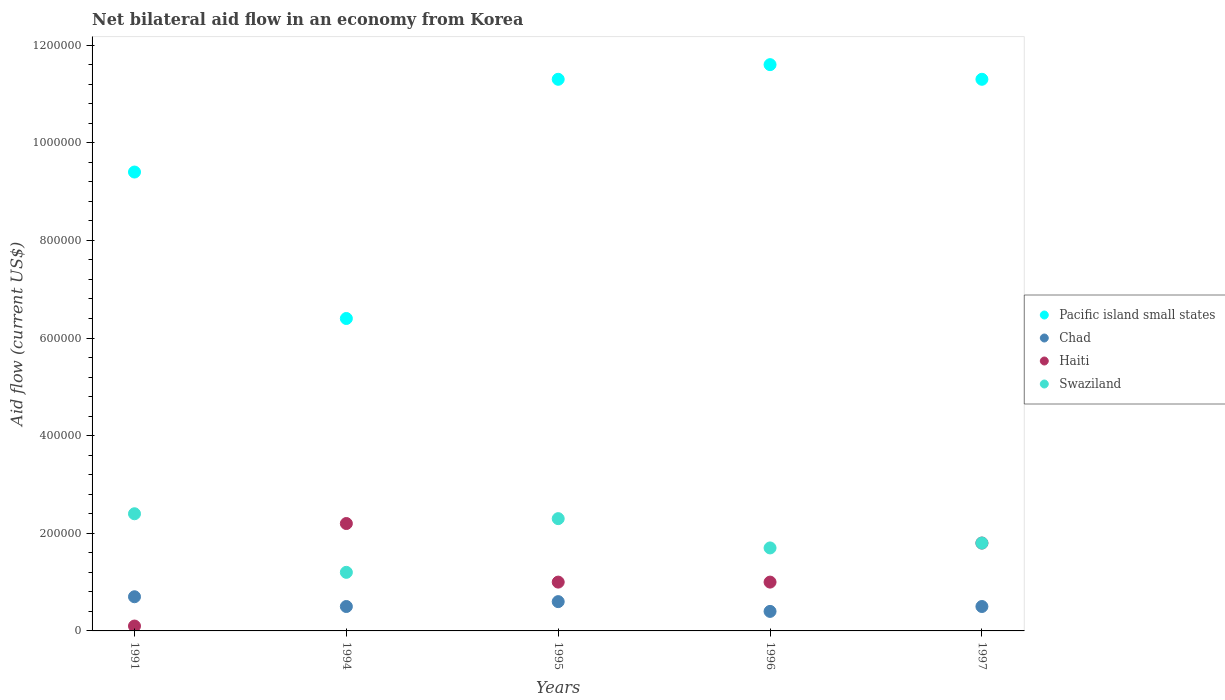What is the net bilateral aid flow in Pacific island small states in 1991?
Provide a short and direct response. 9.40e+05. Across all years, what is the maximum net bilateral aid flow in Swaziland?
Keep it short and to the point. 2.40e+05. Across all years, what is the minimum net bilateral aid flow in Swaziland?
Offer a terse response. 1.20e+05. In which year was the net bilateral aid flow in Chad maximum?
Offer a very short reply. 1991. What is the total net bilateral aid flow in Swaziland in the graph?
Your response must be concise. 9.40e+05. What is the difference between the net bilateral aid flow in Pacific island small states in 1994 and that in 1995?
Make the answer very short. -4.90e+05. What is the difference between the net bilateral aid flow in Haiti in 1991 and the net bilateral aid flow in Swaziland in 1995?
Provide a short and direct response. -2.20e+05. In the year 1994, what is the difference between the net bilateral aid flow in Swaziland and net bilateral aid flow in Pacific island small states?
Your answer should be compact. -5.20e+05. In how many years, is the net bilateral aid flow in Chad greater than 160000 US$?
Make the answer very short. 0. What is the ratio of the net bilateral aid flow in Haiti in 1991 to that in 1994?
Offer a terse response. 0.05. Is the sum of the net bilateral aid flow in Swaziland in 1994 and 1995 greater than the maximum net bilateral aid flow in Pacific island small states across all years?
Make the answer very short. No. Does the net bilateral aid flow in Haiti monotonically increase over the years?
Provide a succinct answer. No. Is the net bilateral aid flow in Pacific island small states strictly less than the net bilateral aid flow in Haiti over the years?
Provide a succinct answer. No. What is the difference between two consecutive major ticks on the Y-axis?
Provide a succinct answer. 2.00e+05. Does the graph contain grids?
Make the answer very short. No. Where does the legend appear in the graph?
Keep it short and to the point. Center right. How many legend labels are there?
Offer a terse response. 4. How are the legend labels stacked?
Ensure brevity in your answer.  Vertical. What is the title of the graph?
Your answer should be compact. Net bilateral aid flow in an economy from Korea. Does "Brazil" appear as one of the legend labels in the graph?
Your response must be concise. No. What is the label or title of the X-axis?
Offer a very short reply. Years. What is the label or title of the Y-axis?
Offer a very short reply. Aid flow (current US$). What is the Aid flow (current US$) of Pacific island small states in 1991?
Your answer should be very brief. 9.40e+05. What is the Aid flow (current US$) in Haiti in 1991?
Make the answer very short. 10000. What is the Aid flow (current US$) of Pacific island small states in 1994?
Ensure brevity in your answer.  6.40e+05. What is the Aid flow (current US$) in Chad in 1994?
Provide a succinct answer. 5.00e+04. What is the Aid flow (current US$) in Pacific island small states in 1995?
Keep it short and to the point. 1.13e+06. What is the Aid flow (current US$) of Chad in 1995?
Keep it short and to the point. 6.00e+04. What is the Aid flow (current US$) in Swaziland in 1995?
Give a very brief answer. 2.30e+05. What is the Aid flow (current US$) of Pacific island small states in 1996?
Provide a short and direct response. 1.16e+06. What is the Aid flow (current US$) in Haiti in 1996?
Offer a very short reply. 1.00e+05. What is the Aid flow (current US$) in Pacific island small states in 1997?
Offer a terse response. 1.13e+06. What is the Aid flow (current US$) in Haiti in 1997?
Offer a very short reply. 1.80e+05. Across all years, what is the maximum Aid flow (current US$) of Pacific island small states?
Give a very brief answer. 1.16e+06. Across all years, what is the maximum Aid flow (current US$) in Swaziland?
Your response must be concise. 2.40e+05. Across all years, what is the minimum Aid flow (current US$) of Pacific island small states?
Offer a very short reply. 6.40e+05. Across all years, what is the minimum Aid flow (current US$) of Haiti?
Your answer should be compact. 10000. What is the total Aid flow (current US$) of Haiti in the graph?
Your answer should be very brief. 6.10e+05. What is the total Aid flow (current US$) of Swaziland in the graph?
Keep it short and to the point. 9.40e+05. What is the difference between the Aid flow (current US$) of Pacific island small states in 1991 and that in 1994?
Provide a short and direct response. 3.00e+05. What is the difference between the Aid flow (current US$) of Swaziland in 1991 and that in 1994?
Offer a very short reply. 1.20e+05. What is the difference between the Aid flow (current US$) in Pacific island small states in 1991 and that in 1995?
Make the answer very short. -1.90e+05. What is the difference between the Aid flow (current US$) of Chad in 1991 and that in 1995?
Offer a terse response. 10000. What is the difference between the Aid flow (current US$) in Swaziland in 1991 and that in 1995?
Keep it short and to the point. 10000. What is the difference between the Aid flow (current US$) in Chad in 1991 and that in 1996?
Offer a terse response. 3.00e+04. What is the difference between the Aid flow (current US$) in Pacific island small states in 1991 and that in 1997?
Offer a terse response. -1.90e+05. What is the difference between the Aid flow (current US$) of Haiti in 1991 and that in 1997?
Offer a terse response. -1.70e+05. What is the difference between the Aid flow (current US$) of Swaziland in 1991 and that in 1997?
Your answer should be very brief. 6.00e+04. What is the difference between the Aid flow (current US$) in Pacific island small states in 1994 and that in 1995?
Your response must be concise. -4.90e+05. What is the difference between the Aid flow (current US$) in Chad in 1994 and that in 1995?
Provide a succinct answer. -10000. What is the difference between the Aid flow (current US$) in Haiti in 1994 and that in 1995?
Offer a terse response. 1.20e+05. What is the difference between the Aid flow (current US$) in Swaziland in 1994 and that in 1995?
Offer a terse response. -1.10e+05. What is the difference between the Aid flow (current US$) of Pacific island small states in 1994 and that in 1996?
Provide a succinct answer. -5.20e+05. What is the difference between the Aid flow (current US$) in Haiti in 1994 and that in 1996?
Provide a short and direct response. 1.20e+05. What is the difference between the Aid flow (current US$) of Swaziland in 1994 and that in 1996?
Provide a succinct answer. -5.00e+04. What is the difference between the Aid flow (current US$) of Pacific island small states in 1994 and that in 1997?
Give a very brief answer. -4.90e+05. What is the difference between the Aid flow (current US$) of Pacific island small states in 1995 and that in 1996?
Make the answer very short. -3.00e+04. What is the difference between the Aid flow (current US$) in Haiti in 1995 and that in 1996?
Make the answer very short. 0. What is the difference between the Aid flow (current US$) of Chad in 1995 and that in 1997?
Give a very brief answer. 10000. What is the difference between the Aid flow (current US$) in Haiti in 1995 and that in 1997?
Provide a short and direct response. -8.00e+04. What is the difference between the Aid flow (current US$) in Haiti in 1996 and that in 1997?
Your response must be concise. -8.00e+04. What is the difference between the Aid flow (current US$) in Pacific island small states in 1991 and the Aid flow (current US$) in Chad in 1994?
Give a very brief answer. 8.90e+05. What is the difference between the Aid flow (current US$) of Pacific island small states in 1991 and the Aid flow (current US$) of Haiti in 1994?
Your response must be concise. 7.20e+05. What is the difference between the Aid flow (current US$) in Pacific island small states in 1991 and the Aid flow (current US$) in Swaziland in 1994?
Your answer should be compact. 8.20e+05. What is the difference between the Aid flow (current US$) of Haiti in 1991 and the Aid flow (current US$) of Swaziland in 1994?
Provide a short and direct response. -1.10e+05. What is the difference between the Aid flow (current US$) in Pacific island small states in 1991 and the Aid flow (current US$) in Chad in 1995?
Make the answer very short. 8.80e+05. What is the difference between the Aid flow (current US$) in Pacific island small states in 1991 and the Aid flow (current US$) in Haiti in 1995?
Your answer should be compact. 8.40e+05. What is the difference between the Aid flow (current US$) of Pacific island small states in 1991 and the Aid flow (current US$) of Swaziland in 1995?
Provide a short and direct response. 7.10e+05. What is the difference between the Aid flow (current US$) in Pacific island small states in 1991 and the Aid flow (current US$) in Chad in 1996?
Make the answer very short. 9.00e+05. What is the difference between the Aid flow (current US$) of Pacific island small states in 1991 and the Aid flow (current US$) of Haiti in 1996?
Your answer should be very brief. 8.40e+05. What is the difference between the Aid flow (current US$) in Pacific island small states in 1991 and the Aid flow (current US$) in Swaziland in 1996?
Make the answer very short. 7.70e+05. What is the difference between the Aid flow (current US$) in Chad in 1991 and the Aid flow (current US$) in Swaziland in 1996?
Give a very brief answer. -1.00e+05. What is the difference between the Aid flow (current US$) in Pacific island small states in 1991 and the Aid flow (current US$) in Chad in 1997?
Your response must be concise. 8.90e+05. What is the difference between the Aid flow (current US$) of Pacific island small states in 1991 and the Aid flow (current US$) of Haiti in 1997?
Your answer should be compact. 7.60e+05. What is the difference between the Aid flow (current US$) in Pacific island small states in 1991 and the Aid flow (current US$) in Swaziland in 1997?
Provide a succinct answer. 7.60e+05. What is the difference between the Aid flow (current US$) in Chad in 1991 and the Aid flow (current US$) in Haiti in 1997?
Make the answer very short. -1.10e+05. What is the difference between the Aid flow (current US$) of Pacific island small states in 1994 and the Aid flow (current US$) of Chad in 1995?
Make the answer very short. 5.80e+05. What is the difference between the Aid flow (current US$) of Pacific island small states in 1994 and the Aid flow (current US$) of Haiti in 1995?
Make the answer very short. 5.40e+05. What is the difference between the Aid flow (current US$) in Pacific island small states in 1994 and the Aid flow (current US$) in Swaziland in 1995?
Give a very brief answer. 4.10e+05. What is the difference between the Aid flow (current US$) in Chad in 1994 and the Aid flow (current US$) in Haiti in 1995?
Your response must be concise. -5.00e+04. What is the difference between the Aid flow (current US$) of Pacific island small states in 1994 and the Aid flow (current US$) of Chad in 1996?
Offer a terse response. 6.00e+05. What is the difference between the Aid flow (current US$) of Pacific island small states in 1994 and the Aid flow (current US$) of Haiti in 1996?
Keep it short and to the point. 5.40e+05. What is the difference between the Aid flow (current US$) of Chad in 1994 and the Aid flow (current US$) of Haiti in 1996?
Keep it short and to the point. -5.00e+04. What is the difference between the Aid flow (current US$) in Pacific island small states in 1994 and the Aid flow (current US$) in Chad in 1997?
Provide a succinct answer. 5.90e+05. What is the difference between the Aid flow (current US$) in Pacific island small states in 1994 and the Aid flow (current US$) in Swaziland in 1997?
Provide a short and direct response. 4.60e+05. What is the difference between the Aid flow (current US$) in Chad in 1994 and the Aid flow (current US$) in Swaziland in 1997?
Offer a terse response. -1.30e+05. What is the difference between the Aid flow (current US$) in Haiti in 1994 and the Aid flow (current US$) in Swaziland in 1997?
Give a very brief answer. 4.00e+04. What is the difference between the Aid flow (current US$) of Pacific island small states in 1995 and the Aid flow (current US$) of Chad in 1996?
Your answer should be very brief. 1.09e+06. What is the difference between the Aid flow (current US$) of Pacific island small states in 1995 and the Aid flow (current US$) of Haiti in 1996?
Provide a succinct answer. 1.03e+06. What is the difference between the Aid flow (current US$) of Pacific island small states in 1995 and the Aid flow (current US$) of Swaziland in 1996?
Your response must be concise. 9.60e+05. What is the difference between the Aid flow (current US$) of Chad in 1995 and the Aid flow (current US$) of Swaziland in 1996?
Your answer should be compact. -1.10e+05. What is the difference between the Aid flow (current US$) of Pacific island small states in 1995 and the Aid flow (current US$) of Chad in 1997?
Your answer should be compact. 1.08e+06. What is the difference between the Aid flow (current US$) in Pacific island small states in 1995 and the Aid flow (current US$) in Haiti in 1997?
Offer a terse response. 9.50e+05. What is the difference between the Aid flow (current US$) of Pacific island small states in 1995 and the Aid flow (current US$) of Swaziland in 1997?
Offer a very short reply. 9.50e+05. What is the difference between the Aid flow (current US$) in Chad in 1995 and the Aid flow (current US$) in Haiti in 1997?
Keep it short and to the point. -1.20e+05. What is the difference between the Aid flow (current US$) of Haiti in 1995 and the Aid flow (current US$) of Swaziland in 1997?
Give a very brief answer. -8.00e+04. What is the difference between the Aid flow (current US$) in Pacific island small states in 1996 and the Aid flow (current US$) in Chad in 1997?
Your answer should be compact. 1.11e+06. What is the difference between the Aid flow (current US$) in Pacific island small states in 1996 and the Aid flow (current US$) in Haiti in 1997?
Give a very brief answer. 9.80e+05. What is the difference between the Aid flow (current US$) of Pacific island small states in 1996 and the Aid flow (current US$) of Swaziland in 1997?
Offer a terse response. 9.80e+05. What is the difference between the Aid flow (current US$) of Chad in 1996 and the Aid flow (current US$) of Haiti in 1997?
Ensure brevity in your answer.  -1.40e+05. What is the difference between the Aid flow (current US$) in Chad in 1996 and the Aid flow (current US$) in Swaziland in 1997?
Offer a very short reply. -1.40e+05. What is the average Aid flow (current US$) of Chad per year?
Give a very brief answer. 5.40e+04. What is the average Aid flow (current US$) in Haiti per year?
Your answer should be very brief. 1.22e+05. What is the average Aid flow (current US$) of Swaziland per year?
Provide a short and direct response. 1.88e+05. In the year 1991, what is the difference between the Aid flow (current US$) in Pacific island small states and Aid flow (current US$) in Chad?
Your answer should be compact. 8.70e+05. In the year 1991, what is the difference between the Aid flow (current US$) in Pacific island small states and Aid flow (current US$) in Haiti?
Offer a terse response. 9.30e+05. In the year 1991, what is the difference between the Aid flow (current US$) in Pacific island small states and Aid flow (current US$) in Swaziland?
Your answer should be compact. 7.00e+05. In the year 1991, what is the difference between the Aid flow (current US$) in Chad and Aid flow (current US$) in Haiti?
Your answer should be very brief. 6.00e+04. In the year 1991, what is the difference between the Aid flow (current US$) in Haiti and Aid flow (current US$) in Swaziland?
Ensure brevity in your answer.  -2.30e+05. In the year 1994, what is the difference between the Aid flow (current US$) of Pacific island small states and Aid flow (current US$) of Chad?
Make the answer very short. 5.90e+05. In the year 1994, what is the difference between the Aid flow (current US$) in Pacific island small states and Aid flow (current US$) in Haiti?
Make the answer very short. 4.20e+05. In the year 1994, what is the difference between the Aid flow (current US$) of Pacific island small states and Aid flow (current US$) of Swaziland?
Your answer should be compact. 5.20e+05. In the year 1994, what is the difference between the Aid flow (current US$) of Chad and Aid flow (current US$) of Swaziland?
Give a very brief answer. -7.00e+04. In the year 1995, what is the difference between the Aid flow (current US$) in Pacific island small states and Aid flow (current US$) in Chad?
Give a very brief answer. 1.07e+06. In the year 1995, what is the difference between the Aid flow (current US$) in Pacific island small states and Aid flow (current US$) in Haiti?
Ensure brevity in your answer.  1.03e+06. In the year 1995, what is the difference between the Aid flow (current US$) in Chad and Aid flow (current US$) in Haiti?
Make the answer very short. -4.00e+04. In the year 1995, what is the difference between the Aid flow (current US$) of Chad and Aid flow (current US$) of Swaziland?
Your response must be concise. -1.70e+05. In the year 1995, what is the difference between the Aid flow (current US$) in Haiti and Aid flow (current US$) in Swaziland?
Offer a terse response. -1.30e+05. In the year 1996, what is the difference between the Aid flow (current US$) in Pacific island small states and Aid flow (current US$) in Chad?
Make the answer very short. 1.12e+06. In the year 1996, what is the difference between the Aid flow (current US$) in Pacific island small states and Aid flow (current US$) in Haiti?
Offer a very short reply. 1.06e+06. In the year 1996, what is the difference between the Aid flow (current US$) in Pacific island small states and Aid flow (current US$) in Swaziland?
Your answer should be very brief. 9.90e+05. In the year 1996, what is the difference between the Aid flow (current US$) in Chad and Aid flow (current US$) in Haiti?
Your response must be concise. -6.00e+04. In the year 1996, what is the difference between the Aid flow (current US$) in Chad and Aid flow (current US$) in Swaziland?
Make the answer very short. -1.30e+05. In the year 1997, what is the difference between the Aid flow (current US$) of Pacific island small states and Aid flow (current US$) of Chad?
Keep it short and to the point. 1.08e+06. In the year 1997, what is the difference between the Aid flow (current US$) in Pacific island small states and Aid flow (current US$) in Haiti?
Make the answer very short. 9.50e+05. In the year 1997, what is the difference between the Aid flow (current US$) of Pacific island small states and Aid flow (current US$) of Swaziland?
Provide a short and direct response. 9.50e+05. In the year 1997, what is the difference between the Aid flow (current US$) in Chad and Aid flow (current US$) in Haiti?
Give a very brief answer. -1.30e+05. In the year 1997, what is the difference between the Aid flow (current US$) in Chad and Aid flow (current US$) in Swaziland?
Provide a succinct answer. -1.30e+05. What is the ratio of the Aid flow (current US$) in Pacific island small states in 1991 to that in 1994?
Keep it short and to the point. 1.47. What is the ratio of the Aid flow (current US$) in Chad in 1991 to that in 1994?
Keep it short and to the point. 1.4. What is the ratio of the Aid flow (current US$) of Haiti in 1991 to that in 1994?
Offer a terse response. 0.05. What is the ratio of the Aid flow (current US$) in Pacific island small states in 1991 to that in 1995?
Offer a terse response. 0.83. What is the ratio of the Aid flow (current US$) of Swaziland in 1991 to that in 1995?
Provide a succinct answer. 1.04. What is the ratio of the Aid flow (current US$) in Pacific island small states in 1991 to that in 1996?
Make the answer very short. 0.81. What is the ratio of the Aid flow (current US$) in Chad in 1991 to that in 1996?
Your answer should be very brief. 1.75. What is the ratio of the Aid flow (current US$) of Haiti in 1991 to that in 1996?
Your response must be concise. 0.1. What is the ratio of the Aid flow (current US$) of Swaziland in 1991 to that in 1996?
Keep it short and to the point. 1.41. What is the ratio of the Aid flow (current US$) in Pacific island small states in 1991 to that in 1997?
Keep it short and to the point. 0.83. What is the ratio of the Aid flow (current US$) of Chad in 1991 to that in 1997?
Your response must be concise. 1.4. What is the ratio of the Aid flow (current US$) of Haiti in 1991 to that in 1997?
Offer a terse response. 0.06. What is the ratio of the Aid flow (current US$) of Swaziland in 1991 to that in 1997?
Keep it short and to the point. 1.33. What is the ratio of the Aid flow (current US$) of Pacific island small states in 1994 to that in 1995?
Your answer should be very brief. 0.57. What is the ratio of the Aid flow (current US$) in Chad in 1994 to that in 1995?
Provide a short and direct response. 0.83. What is the ratio of the Aid flow (current US$) in Haiti in 1994 to that in 1995?
Your response must be concise. 2.2. What is the ratio of the Aid flow (current US$) in Swaziland in 1994 to that in 1995?
Your answer should be very brief. 0.52. What is the ratio of the Aid flow (current US$) in Pacific island small states in 1994 to that in 1996?
Ensure brevity in your answer.  0.55. What is the ratio of the Aid flow (current US$) of Chad in 1994 to that in 1996?
Make the answer very short. 1.25. What is the ratio of the Aid flow (current US$) in Haiti in 1994 to that in 1996?
Your answer should be compact. 2.2. What is the ratio of the Aid flow (current US$) of Swaziland in 1994 to that in 1996?
Your answer should be compact. 0.71. What is the ratio of the Aid flow (current US$) of Pacific island small states in 1994 to that in 1997?
Keep it short and to the point. 0.57. What is the ratio of the Aid flow (current US$) in Chad in 1994 to that in 1997?
Your answer should be compact. 1. What is the ratio of the Aid flow (current US$) of Haiti in 1994 to that in 1997?
Provide a short and direct response. 1.22. What is the ratio of the Aid flow (current US$) of Pacific island small states in 1995 to that in 1996?
Your response must be concise. 0.97. What is the ratio of the Aid flow (current US$) of Chad in 1995 to that in 1996?
Give a very brief answer. 1.5. What is the ratio of the Aid flow (current US$) in Haiti in 1995 to that in 1996?
Ensure brevity in your answer.  1. What is the ratio of the Aid flow (current US$) of Swaziland in 1995 to that in 1996?
Your response must be concise. 1.35. What is the ratio of the Aid flow (current US$) in Pacific island small states in 1995 to that in 1997?
Ensure brevity in your answer.  1. What is the ratio of the Aid flow (current US$) of Chad in 1995 to that in 1997?
Provide a succinct answer. 1.2. What is the ratio of the Aid flow (current US$) in Haiti in 1995 to that in 1997?
Your answer should be compact. 0.56. What is the ratio of the Aid flow (current US$) of Swaziland in 1995 to that in 1997?
Offer a terse response. 1.28. What is the ratio of the Aid flow (current US$) in Pacific island small states in 1996 to that in 1997?
Offer a terse response. 1.03. What is the ratio of the Aid flow (current US$) in Chad in 1996 to that in 1997?
Make the answer very short. 0.8. What is the ratio of the Aid flow (current US$) of Haiti in 1996 to that in 1997?
Give a very brief answer. 0.56. What is the difference between the highest and the second highest Aid flow (current US$) in Pacific island small states?
Offer a very short reply. 3.00e+04. What is the difference between the highest and the second highest Aid flow (current US$) of Chad?
Your answer should be compact. 10000. What is the difference between the highest and the second highest Aid flow (current US$) of Haiti?
Keep it short and to the point. 4.00e+04. What is the difference between the highest and the lowest Aid flow (current US$) in Pacific island small states?
Keep it short and to the point. 5.20e+05. 